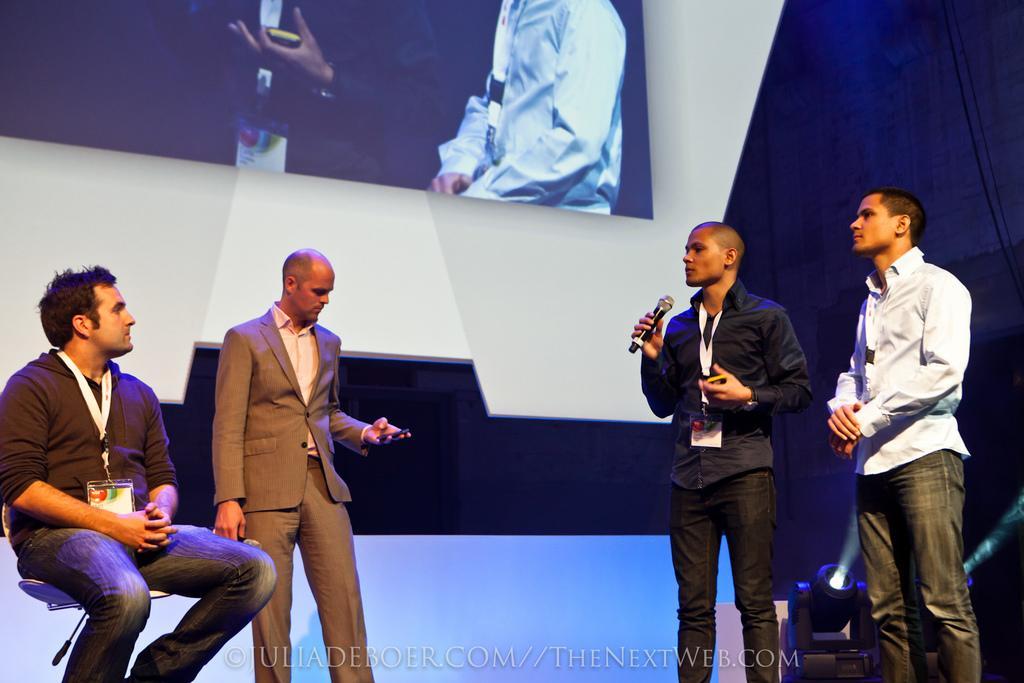Could you give a brief overview of what you see in this image? Here we can see four people. This person wore ID card and sitting on a chair. This man wore a suit and looking at his mobile. Another man wore ID card, holding mobile with one hand and holding mic with another hand. Here we can see focusing lights. Top of the image there is a screen. Bottom of the image there is a watermark.  